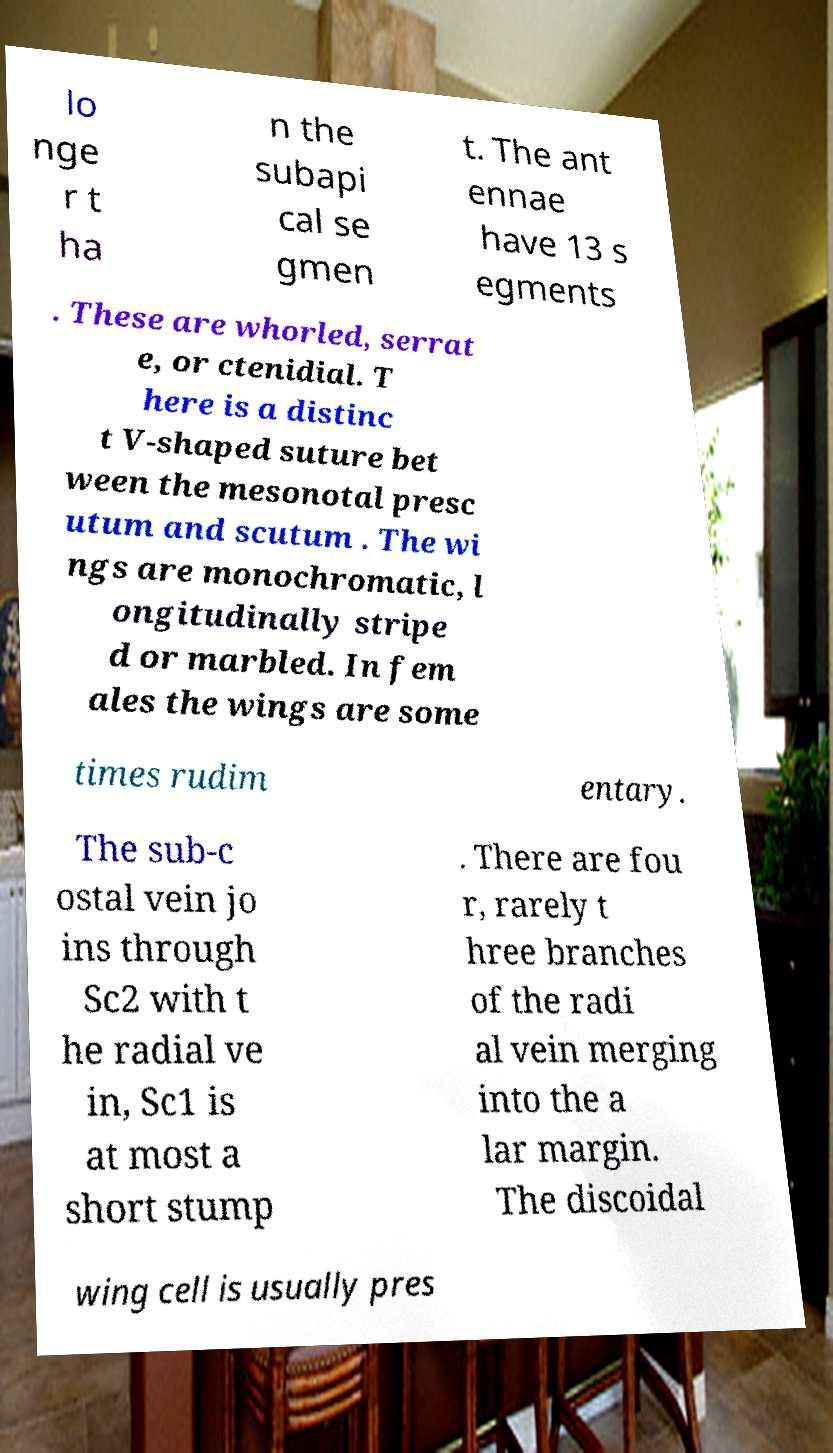Can you read and provide the text displayed in the image?This photo seems to have some interesting text. Can you extract and type it out for me? lo nge r t ha n the subapi cal se gmen t. The ant ennae have 13 s egments . These are whorled, serrat e, or ctenidial. T here is a distinc t V-shaped suture bet ween the mesonotal presc utum and scutum . The wi ngs are monochromatic, l ongitudinally stripe d or marbled. In fem ales the wings are some times rudim entary. The sub-c ostal vein jo ins through Sc2 with t he radial ve in, Sc1 is at most a short stump . There are fou r, rarely t hree branches of the radi al vein merging into the a lar margin. The discoidal wing cell is usually pres 